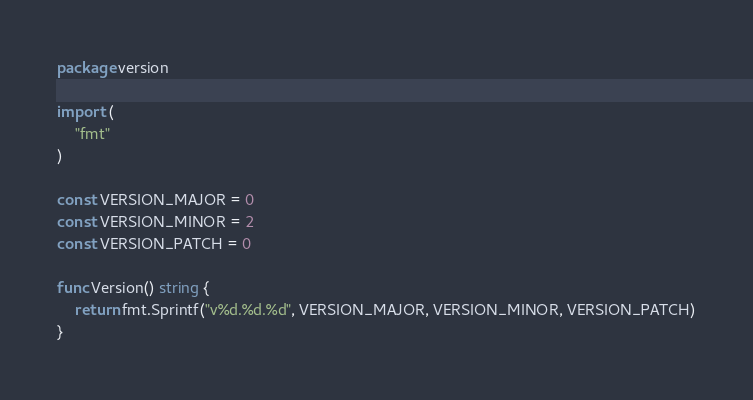<code> <loc_0><loc_0><loc_500><loc_500><_Go_>package version

import (
	"fmt"
)

const VERSION_MAJOR = 0
const VERSION_MINOR = 2
const VERSION_PATCH = 0

func Version() string {
	return fmt.Sprintf("v%d.%d.%d", VERSION_MAJOR, VERSION_MINOR, VERSION_PATCH)
}
</code> 